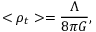<formula> <loc_0><loc_0><loc_500><loc_500>< \rho _ { t } > = \frac { \Lambda } { 8 \pi G } ,</formula> 